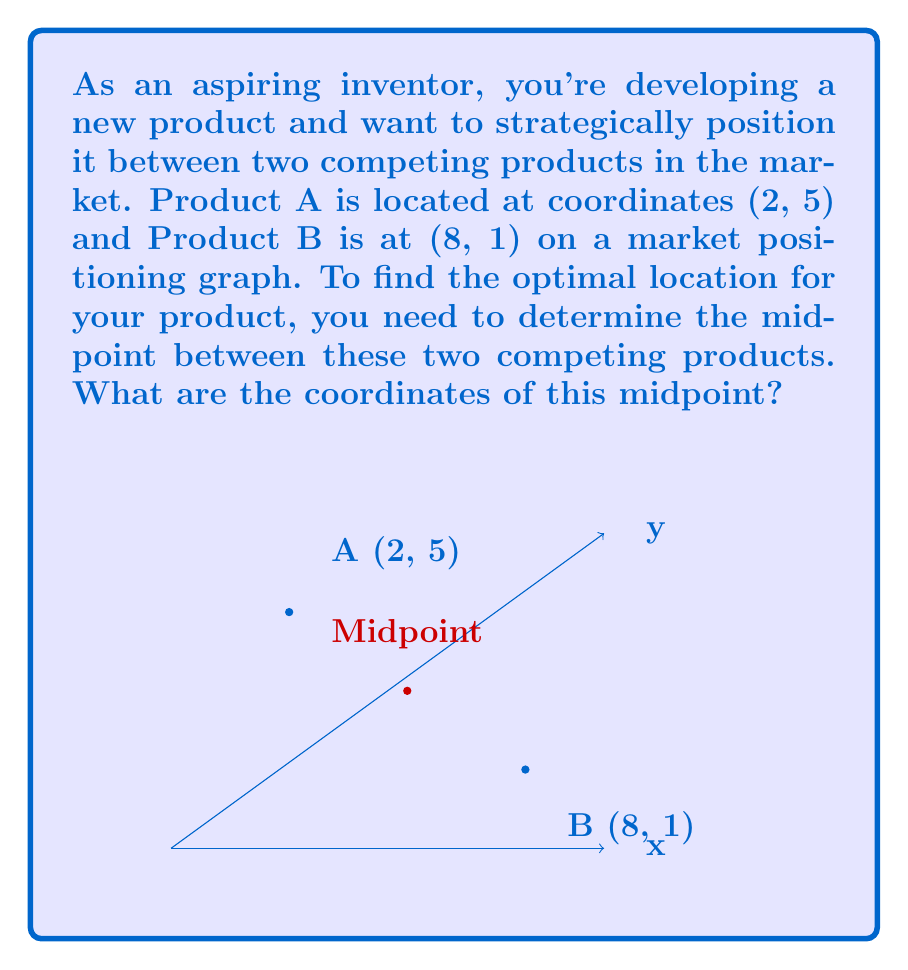Give your solution to this math problem. To find the midpoint between two points on a coordinate plane, we use the midpoint formula:

$$ \text{Midpoint} = \left(\frac{x_1 + x_2}{2}, \frac{y_1 + y_2}{2}\right) $$

Where $(x_1, y_1)$ are the coordinates of the first point and $(x_2, y_2)$ are the coordinates of the second point.

Given:
- Product A is at (2, 5)
- Product B is at (8, 1)

Step 1: Identify the x and y coordinates for each point.
$x_1 = 2$, $y_1 = 5$
$x_2 = 8$, $y_2 = 1$

Step 2: Apply the midpoint formula for the x-coordinate.
$$ x_{\text{midpoint}} = \frac{x_1 + x_2}{2} = \frac{2 + 8}{2} = \frac{10}{2} = 5 $$

Step 3: Apply the midpoint formula for the y-coordinate.
$$ y_{\text{midpoint}} = \frac{y_1 + y_2}{2} = \frac{5 + 1}{2} = \frac{6}{2} = 3 $$

Step 4: Combine the results to get the midpoint coordinates.
Midpoint = (5, 3)

This point represents the optimal location for your product in the market positioning graph, equally distant from both competing products.
Answer: (5, 3) 